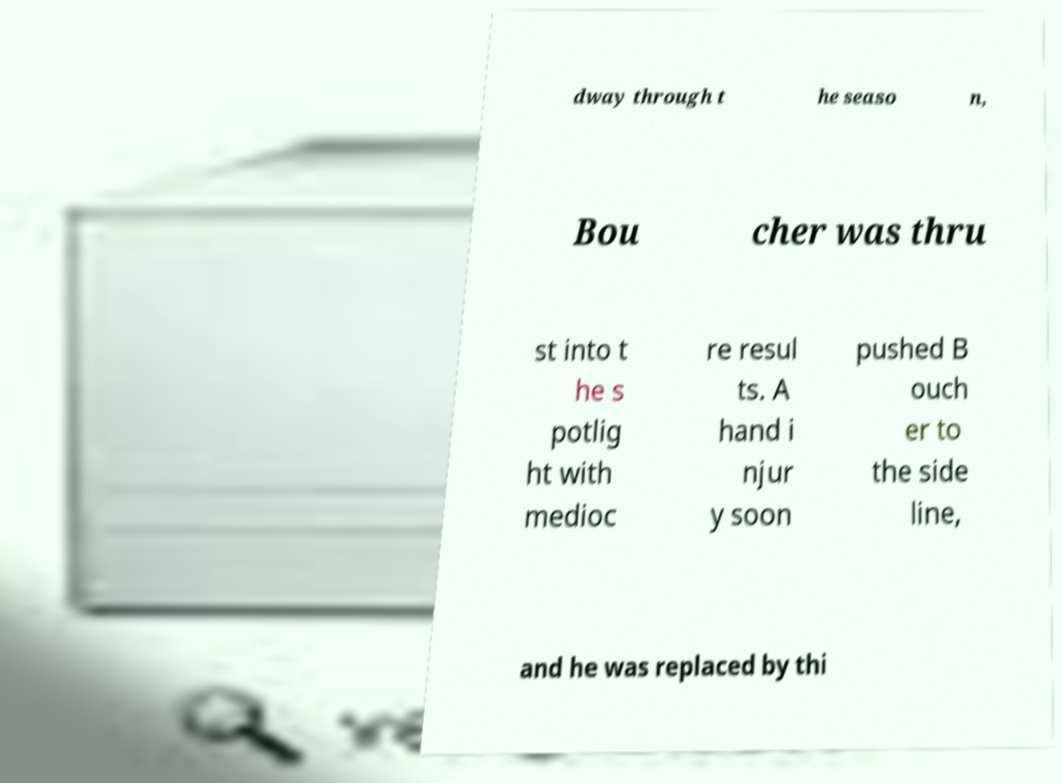Can you read and provide the text displayed in the image?This photo seems to have some interesting text. Can you extract and type it out for me? dway through t he seaso n, Bou cher was thru st into t he s potlig ht with medioc re resul ts. A hand i njur y soon pushed B ouch er to the side line, and he was replaced by thi 